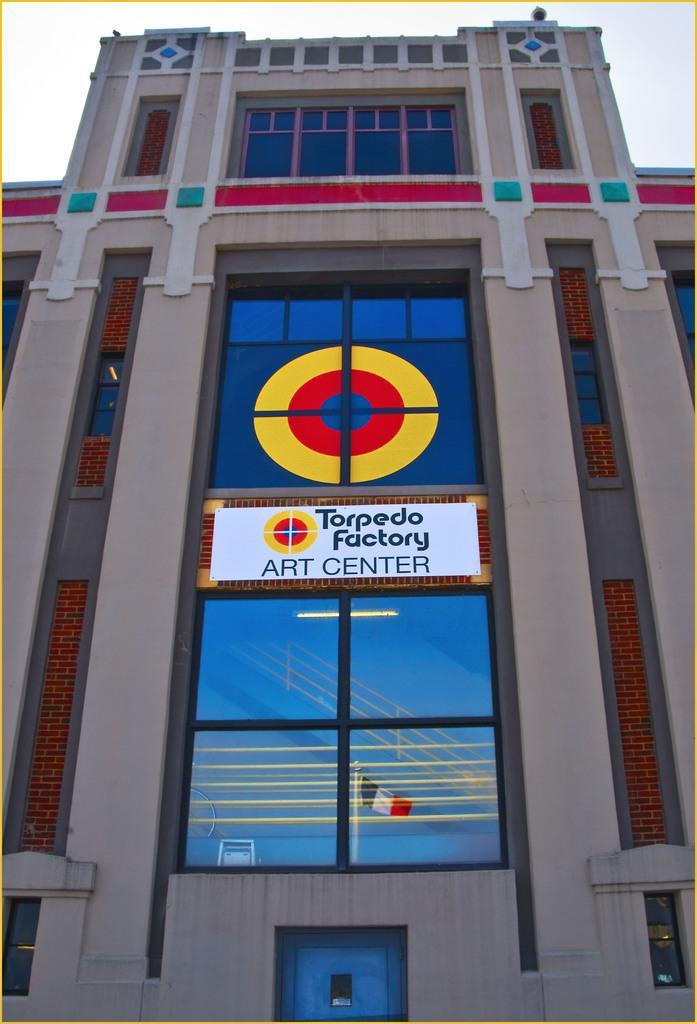How would you summarize this image in a sentence or two? The picture consists of a building. In the center of the picture there is a glass window and text. At the bottom there is door. 